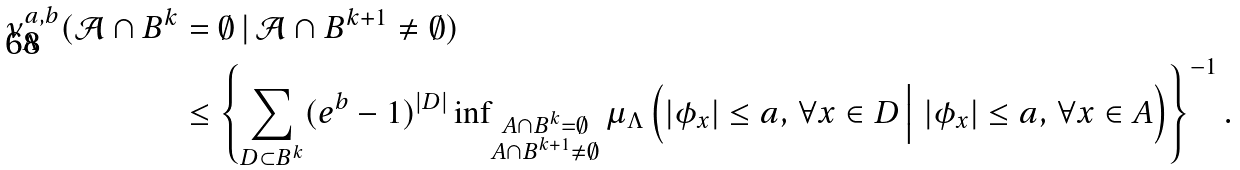<formula> <loc_0><loc_0><loc_500><loc_500>\nu _ { \Lambda } ^ { a , b } ( \mathcal { A } \cap B ^ { k } & = \emptyset \, | \, \mathcal { A } \cap B ^ { k + 1 } \neq \emptyset ) \\ & \leq \left \{ \sum _ { D \subset B ^ { k } } ( e ^ { b } - 1 ) ^ { \left | D \right | } \inf \nolimits _ { \substack { A \cap B ^ { k } = \emptyset \\ A \cap B ^ { k + 1 } \neq \emptyset } } \mu _ { \Lambda } \left ( \left | \phi _ { x } \right | \leq a , \, \forall x \in D \, \Big | \, \left | \phi _ { x } \right | \leq a , \, \forall x \in A \right ) \right \} ^ { - 1 } .</formula> 